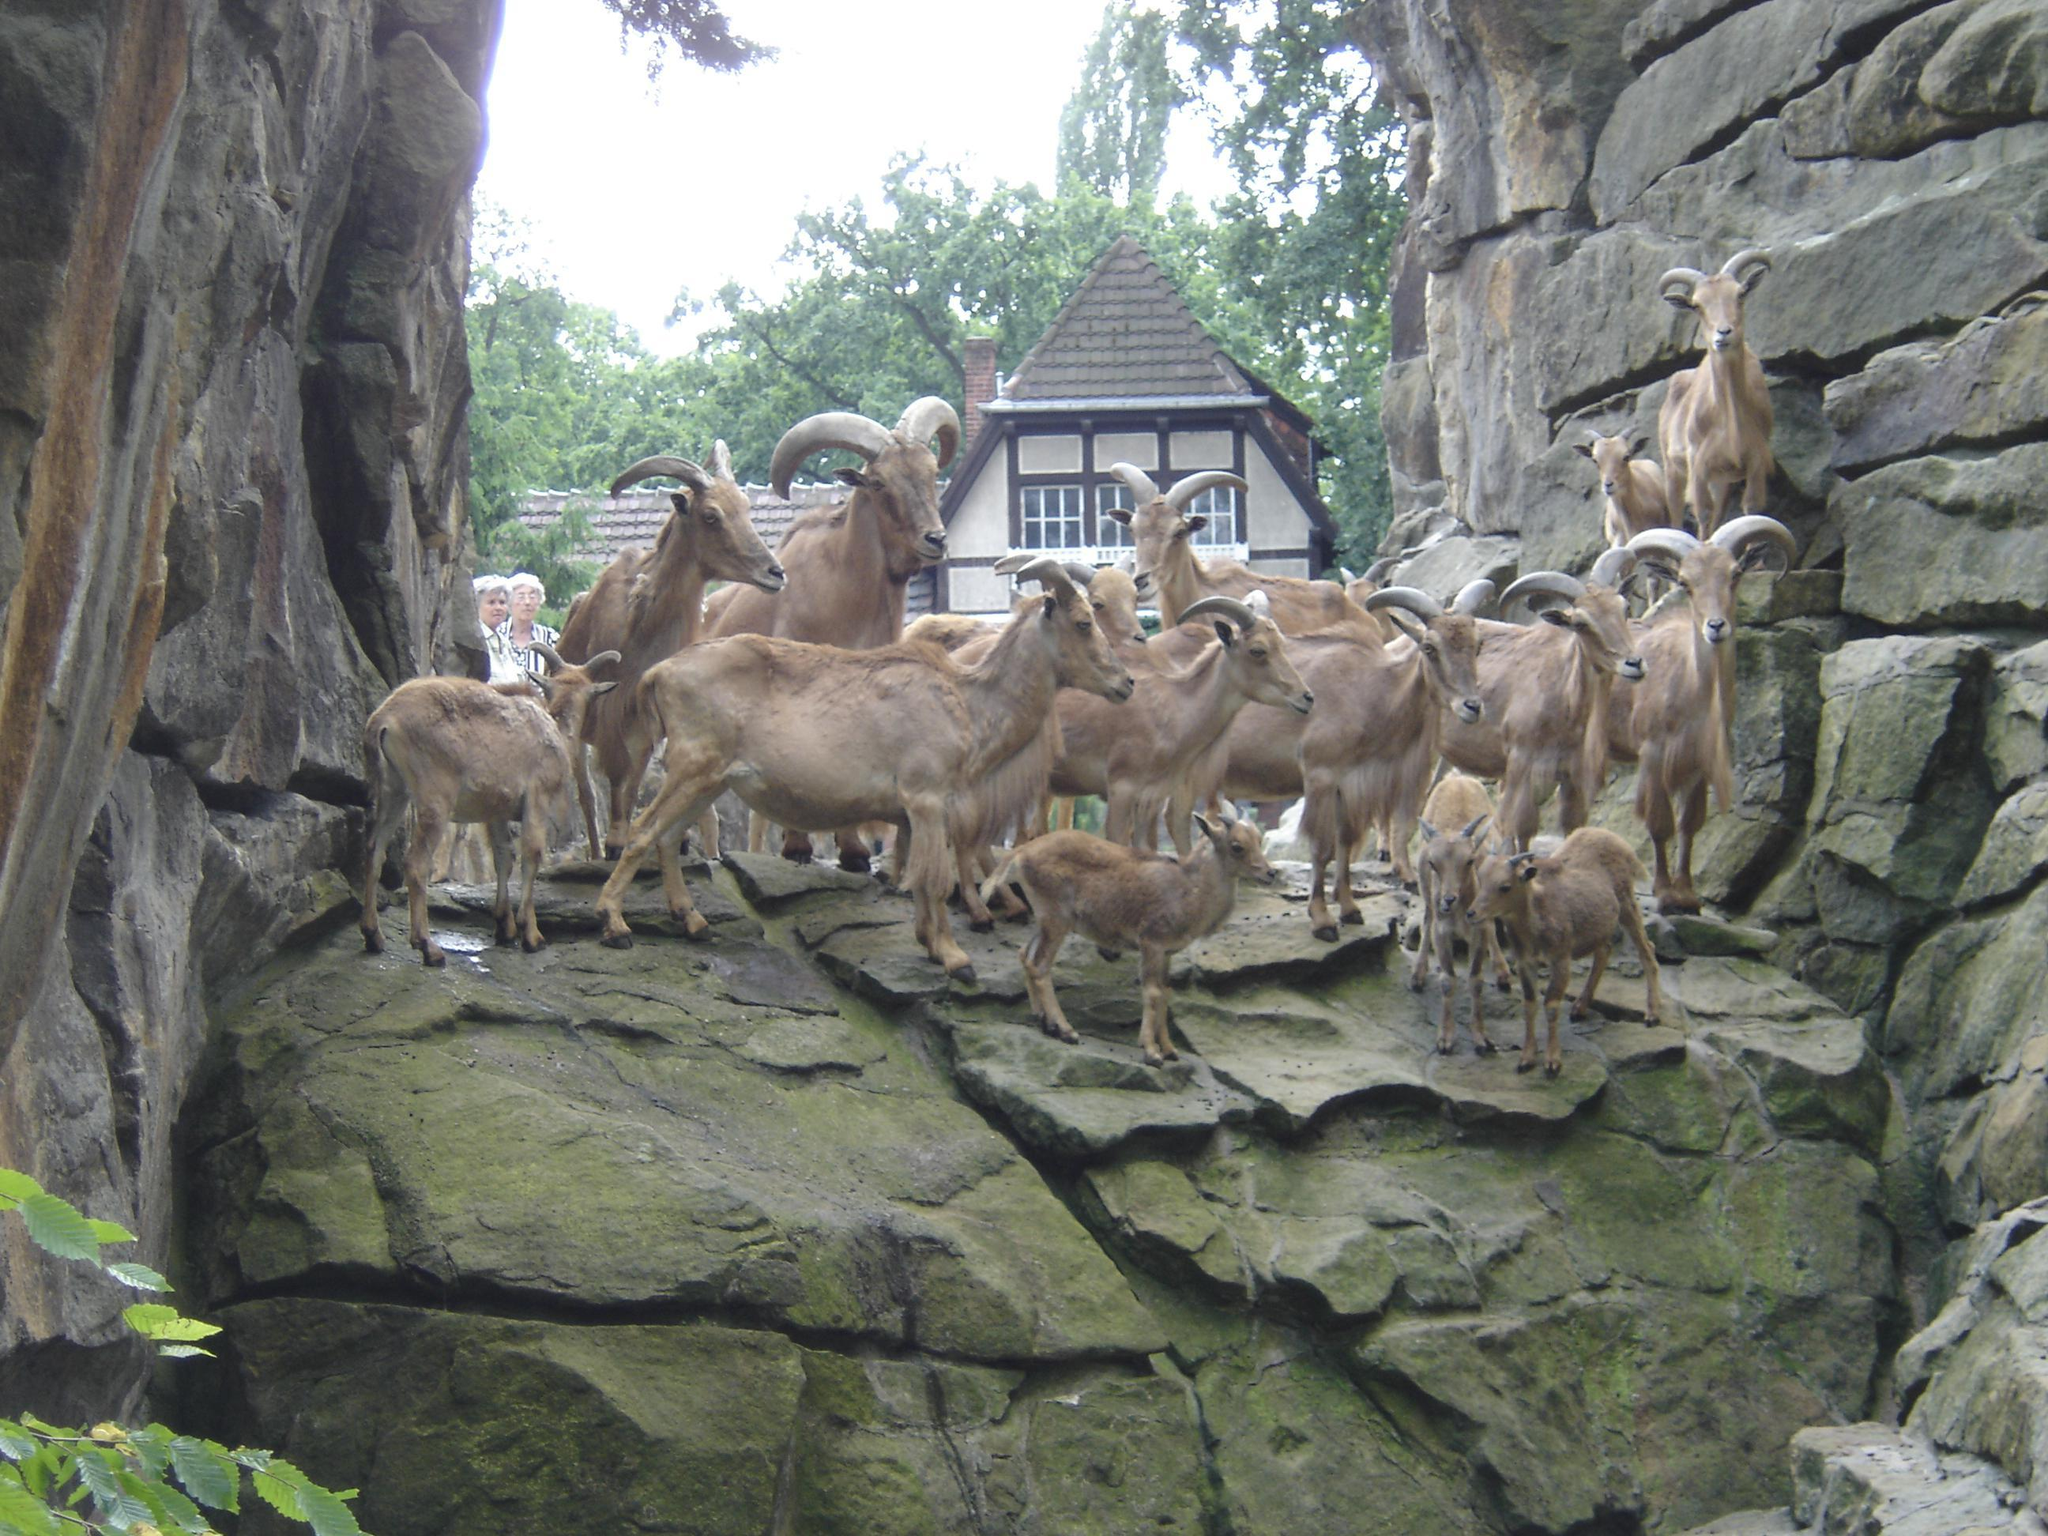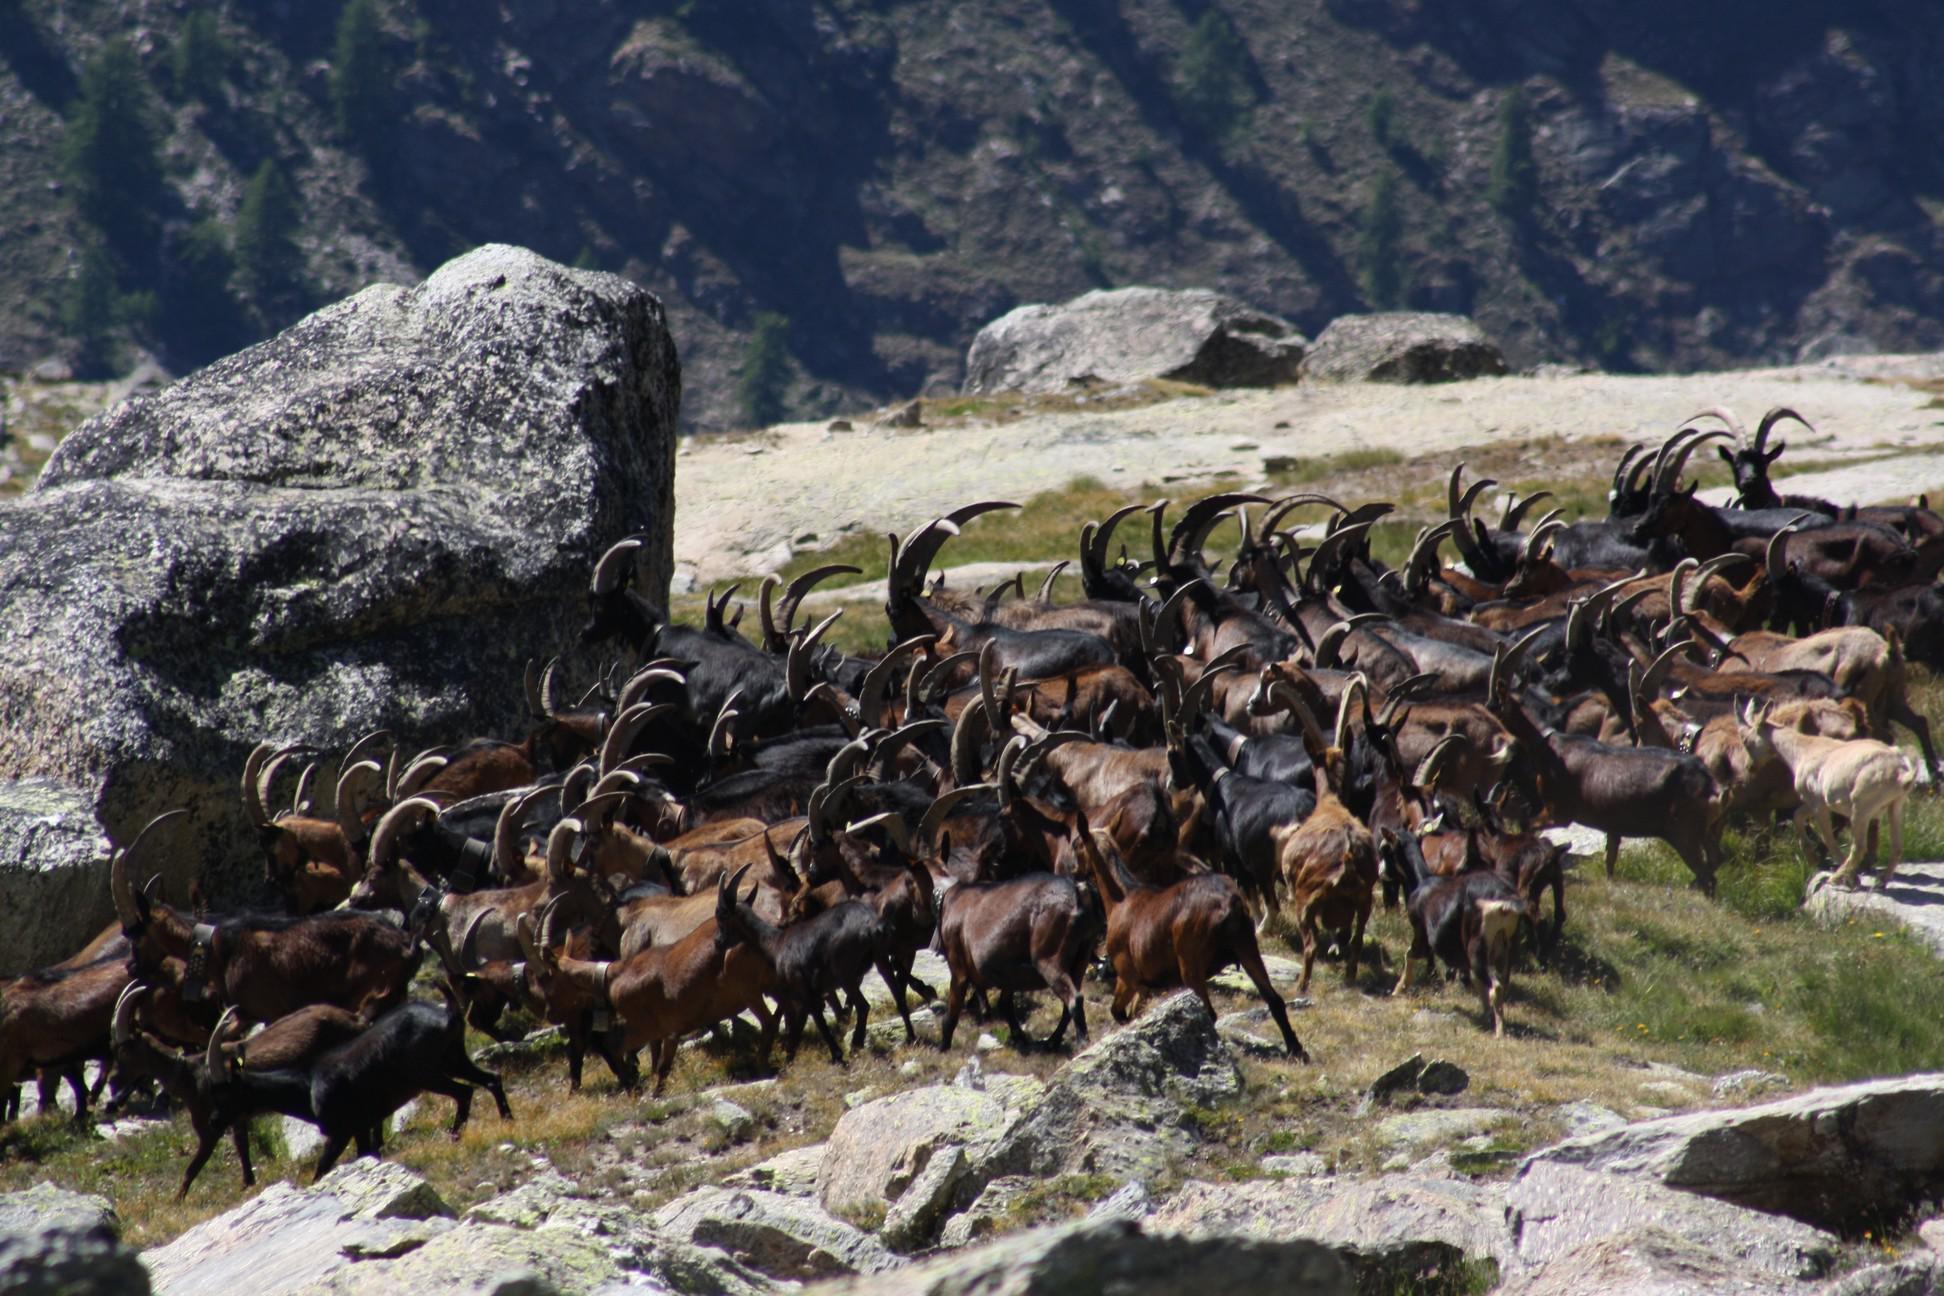The first image is the image on the left, the second image is the image on the right. Given the left and right images, does the statement "the animals in the image on the left are on grass" hold true? Answer yes or no. No. The first image is the image on the left, the second image is the image on the right. Assess this claim about the two images: "The roof of a structure is visible in an image containing a horned goat.". Correct or not? Answer yes or no. Yes. 